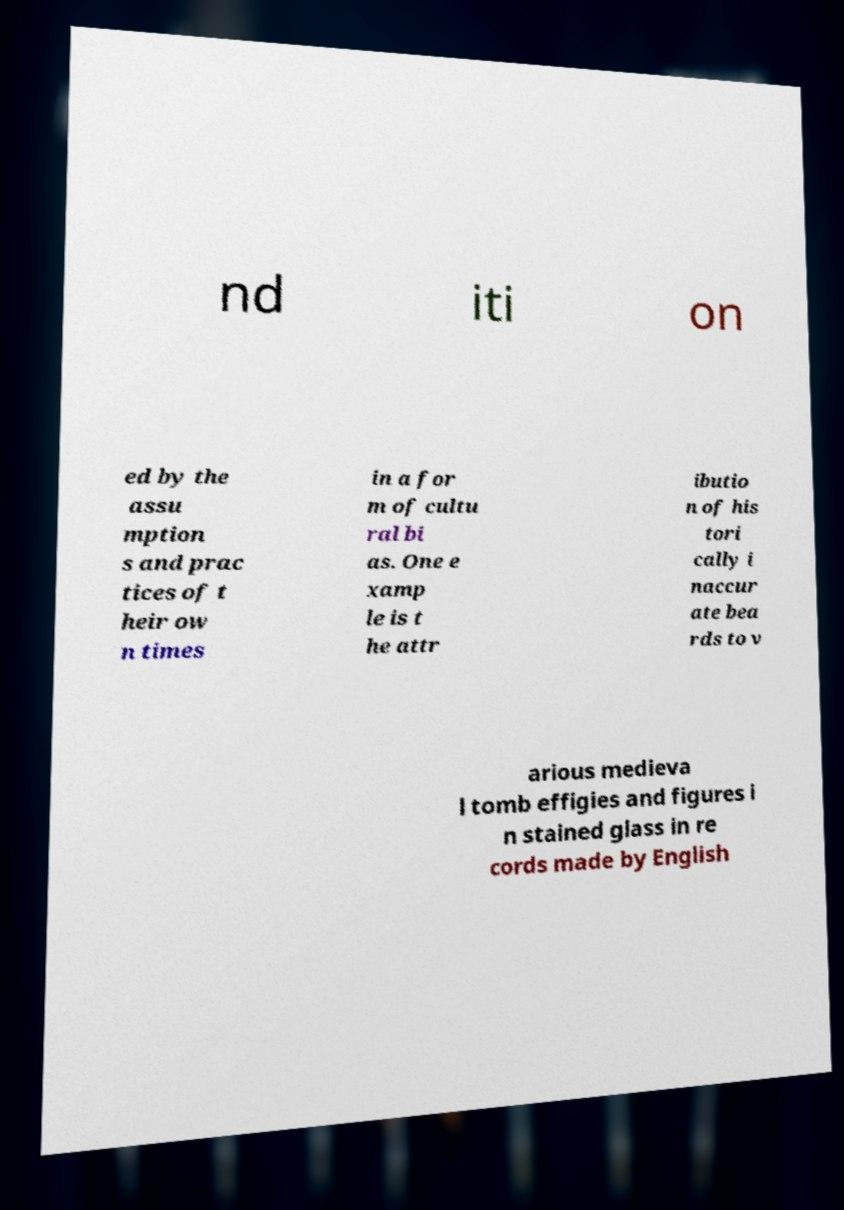Can you read and provide the text displayed in the image?This photo seems to have some interesting text. Can you extract and type it out for me? nd iti on ed by the assu mption s and prac tices of t heir ow n times in a for m of cultu ral bi as. One e xamp le is t he attr ibutio n of his tori cally i naccur ate bea rds to v arious medieva l tomb effigies and figures i n stained glass in re cords made by English 